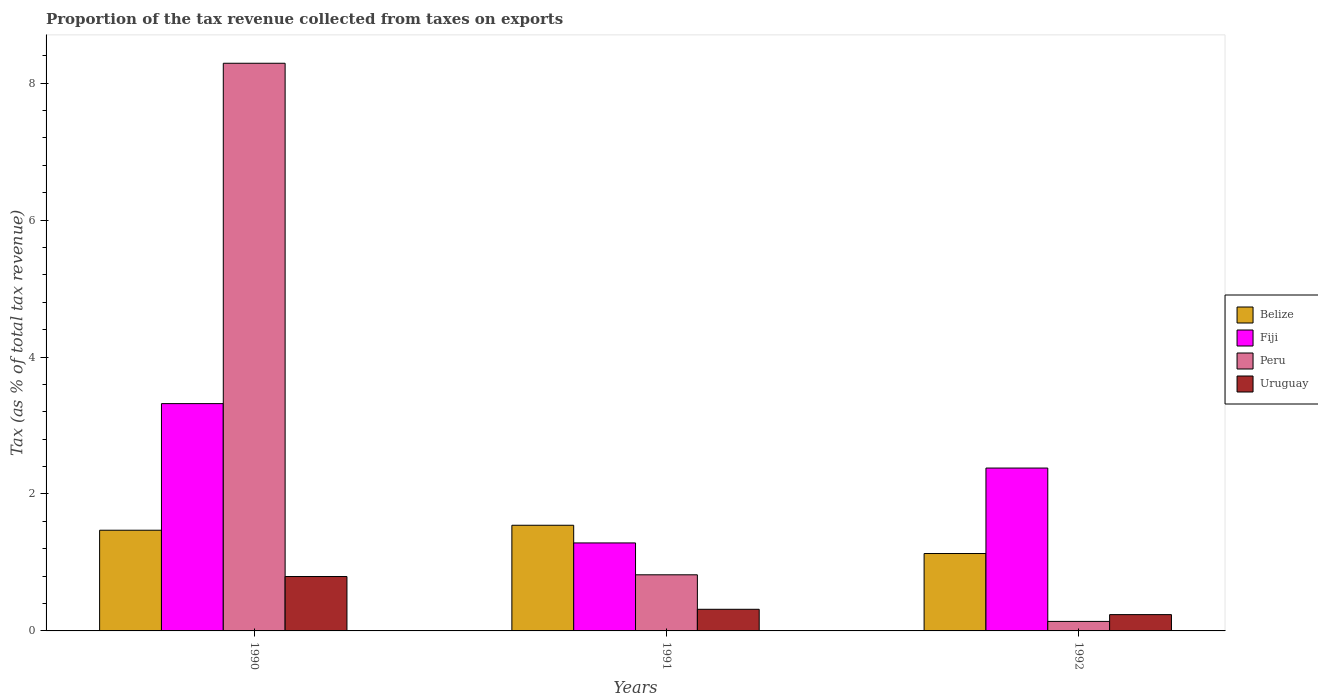How many different coloured bars are there?
Your response must be concise. 4. Are the number of bars per tick equal to the number of legend labels?
Give a very brief answer. Yes. In how many cases, is the number of bars for a given year not equal to the number of legend labels?
Provide a short and direct response. 0. What is the proportion of the tax revenue collected in Peru in 1992?
Ensure brevity in your answer.  0.14. Across all years, what is the maximum proportion of the tax revenue collected in Uruguay?
Offer a very short reply. 0.79. Across all years, what is the minimum proportion of the tax revenue collected in Belize?
Your answer should be compact. 1.13. What is the total proportion of the tax revenue collected in Peru in the graph?
Make the answer very short. 9.25. What is the difference between the proportion of the tax revenue collected in Fiji in 1991 and that in 1992?
Provide a succinct answer. -1.09. What is the difference between the proportion of the tax revenue collected in Uruguay in 1992 and the proportion of the tax revenue collected in Belize in 1990?
Ensure brevity in your answer.  -1.23. What is the average proportion of the tax revenue collected in Fiji per year?
Keep it short and to the point. 2.33. In the year 1990, what is the difference between the proportion of the tax revenue collected in Belize and proportion of the tax revenue collected in Fiji?
Offer a terse response. -1.85. In how many years, is the proportion of the tax revenue collected in Fiji greater than 7.2 %?
Provide a succinct answer. 0. What is the ratio of the proportion of the tax revenue collected in Uruguay in 1990 to that in 1991?
Keep it short and to the point. 2.51. Is the proportion of the tax revenue collected in Belize in 1990 less than that in 1991?
Offer a very short reply. Yes. What is the difference between the highest and the second highest proportion of the tax revenue collected in Belize?
Ensure brevity in your answer.  0.07. What is the difference between the highest and the lowest proportion of the tax revenue collected in Belize?
Your response must be concise. 0.41. In how many years, is the proportion of the tax revenue collected in Belize greater than the average proportion of the tax revenue collected in Belize taken over all years?
Give a very brief answer. 2. Is it the case that in every year, the sum of the proportion of the tax revenue collected in Belize and proportion of the tax revenue collected in Peru is greater than the sum of proportion of the tax revenue collected in Fiji and proportion of the tax revenue collected in Uruguay?
Offer a very short reply. No. What does the 1st bar from the left in 1991 represents?
Keep it short and to the point. Belize. What does the 4th bar from the right in 1991 represents?
Your answer should be compact. Belize. How many bars are there?
Your answer should be compact. 12. Does the graph contain any zero values?
Provide a succinct answer. No. Where does the legend appear in the graph?
Ensure brevity in your answer.  Center right. How many legend labels are there?
Your answer should be very brief. 4. What is the title of the graph?
Your answer should be compact. Proportion of the tax revenue collected from taxes on exports. What is the label or title of the Y-axis?
Your response must be concise. Tax (as % of total tax revenue). What is the Tax (as % of total tax revenue) in Belize in 1990?
Give a very brief answer. 1.47. What is the Tax (as % of total tax revenue) of Fiji in 1990?
Ensure brevity in your answer.  3.32. What is the Tax (as % of total tax revenue) of Peru in 1990?
Your answer should be compact. 8.29. What is the Tax (as % of total tax revenue) of Uruguay in 1990?
Keep it short and to the point. 0.79. What is the Tax (as % of total tax revenue) in Belize in 1991?
Provide a short and direct response. 1.54. What is the Tax (as % of total tax revenue) of Fiji in 1991?
Ensure brevity in your answer.  1.29. What is the Tax (as % of total tax revenue) of Peru in 1991?
Give a very brief answer. 0.82. What is the Tax (as % of total tax revenue) of Uruguay in 1991?
Your answer should be very brief. 0.32. What is the Tax (as % of total tax revenue) of Belize in 1992?
Provide a short and direct response. 1.13. What is the Tax (as % of total tax revenue) in Fiji in 1992?
Your answer should be compact. 2.38. What is the Tax (as % of total tax revenue) in Peru in 1992?
Your response must be concise. 0.14. What is the Tax (as % of total tax revenue) of Uruguay in 1992?
Give a very brief answer. 0.24. Across all years, what is the maximum Tax (as % of total tax revenue) in Belize?
Your answer should be compact. 1.54. Across all years, what is the maximum Tax (as % of total tax revenue) in Fiji?
Your answer should be very brief. 3.32. Across all years, what is the maximum Tax (as % of total tax revenue) of Peru?
Your response must be concise. 8.29. Across all years, what is the maximum Tax (as % of total tax revenue) in Uruguay?
Provide a succinct answer. 0.79. Across all years, what is the minimum Tax (as % of total tax revenue) in Belize?
Your answer should be compact. 1.13. Across all years, what is the minimum Tax (as % of total tax revenue) in Fiji?
Your answer should be very brief. 1.29. Across all years, what is the minimum Tax (as % of total tax revenue) in Peru?
Your answer should be very brief. 0.14. Across all years, what is the minimum Tax (as % of total tax revenue) in Uruguay?
Your answer should be compact. 0.24. What is the total Tax (as % of total tax revenue) in Belize in the graph?
Keep it short and to the point. 4.14. What is the total Tax (as % of total tax revenue) in Fiji in the graph?
Your answer should be very brief. 6.98. What is the total Tax (as % of total tax revenue) of Peru in the graph?
Ensure brevity in your answer.  9.25. What is the total Tax (as % of total tax revenue) in Uruguay in the graph?
Make the answer very short. 1.35. What is the difference between the Tax (as % of total tax revenue) in Belize in 1990 and that in 1991?
Your answer should be compact. -0.07. What is the difference between the Tax (as % of total tax revenue) of Fiji in 1990 and that in 1991?
Keep it short and to the point. 2.03. What is the difference between the Tax (as % of total tax revenue) of Peru in 1990 and that in 1991?
Give a very brief answer. 7.47. What is the difference between the Tax (as % of total tax revenue) of Uruguay in 1990 and that in 1991?
Your answer should be very brief. 0.48. What is the difference between the Tax (as % of total tax revenue) in Belize in 1990 and that in 1992?
Offer a very short reply. 0.34. What is the difference between the Tax (as % of total tax revenue) of Fiji in 1990 and that in 1992?
Keep it short and to the point. 0.94. What is the difference between the Tax (as % of total tax revenue) of Peru in 1990 and that in 1992?
Your answer should be very brief. 8.15. What is the difference between the Tax (as % of total tax revenue) of Uruguay in 1990 and that in 1992?
Make the answer very short. 0.56. What is the difference between the Tax (as % of total tax revenue) in Belize in 1991 and that in 1992?
Provide a succinct answer. 0.41. What is the difference between the Tax (as % of total tax revenue) in Fiji in 1991 and that in 1992?
Keep it short and to the point. -1.09. What is the difference between the Tax (as % of total tax revenue) in Peru in 1991 and that in 1992?
Ensure brevity in your answer.  0.68. What is the difference between the Tax (as % of total tax revenue) in Uruguay in 1991 and that in 1992?
Keep it short and to the point. 0.08. What is the difference between the Tax (as % of total tax revenue) in Belize in 1990 and the Tax (as % of total tax revenue) in Fiji in 1991?
Ensure brevity in your answer.  0.19. What is the difference between the Tax (as % of total tax revenue) of Belize in 1990 and the Tax (as % of total tax revenue) of Peru in 1991?
Your answer should be very brief. 0.65. What is the difference between the Tax (as % of total tax revenue) of Belize in 1990 and the Tax (as % of total tax revenue) of Uruguay in 1991?
Make the answer very short. 1.15. What is the difference between the Tax (as % of total tax revenue) of Fiji in 1990 and the Tax (as % of total tax revenue) of Peru in 1991?
Provide a succinct answer. 2.5. What is the difference between the Tax (as % of total tax revenue) in Fiji in 1990 and the Tax (as % of total tax revenue) in Uruguay in 1991?
Offer a terse response. 3. What is the difference between the Tax (as % of total tax revenue) in Peru in 1990 and the Tax (as % of total tax revenue) in Uruguay in 1991?
Your response must be concise. 7.98. What is the difference between the Tax (as % of total tax revenue) in Belize in 1990 and the Tax (as % of total tax revenue) in Fiji in 1992?
Your response must be concise. -0.91. What is the difference between the Tax (as % of total tax revenue) in Belize in 1990 and the Tax (as % of total tax revenue) in Peru in 1992?
Provide a succinct answer. 1.33. What is the difference between the Tax (as % of total tax revenue) in Belize in 1990 and the Tax (as % of total tax revenue) in Uruguay in 1992?
Offer a very short reply. 1.23. What is the difference between the Tax (as % of total tax revenue) of Fiji in 1990 and the Tax (as % of total tax revenue) of Peru in 1992?
Keep it short and to the point. 3.18. What is the difference between the Tax (as % of total tax revenue) of Fiji in 1990 and the Tax (as % of total tax revenue) of Uruguay in 1992?
Offer a terse response. 3.08. What is the difference between the Tax (as % of total tax revenue) in Peru in 1990 and the Tax (as % of total tax revenue) in Uruguay in 1992?
Make the answer very short. 8.05. What is the difference between the Tax (as % of total tax revenue) in Belize in 1991 and the Tax (as % of total tax revenue) in Fiji in 1992?
Give a very brief answer. -0.84. What is the difference between the Tax (as % of total tax revenue) of Belize in 1991 and the Tax (as % of total tax revenue) of Peru in 1992?
Your answer should be very brief. 1.4. What is the difference between the Tax (as % of total tax revenue) in Belize in 1991 and the Tax (as % of total tax revenue) in Uruguay in 1992?
Your answer should be compact. 1.31. What is the difference between the Tax (as % of total tax revenue) of Fiji in 1991 and the Tax (as % of total tax revenue) of Peru in 1992?
Give a very brief answer. 1.15. What is the difference between the Tax (as % of total tax revenue) in Fiji in 1991 and the Tax (as % of total tax revenue) in Uruguay in 1992?
Offer a terse response. 1.05. What is the difference between the Tax (as % of total tax revenue) in Peru in 1991 and the Tax (as % of total tax revenue) in Uruguay in 1992?
Provide a short and direct response. 0.58. What is the average Tax (as % of total tax revenue) of Belize per year?
Your response must be concise. 1.38. What is the average Tax (as % of total tax revenue) in Fiji per year?
Provide a short and direct response. 2.33. What is the average Tax (as % of total tax revenue) in Peru per year?
Make the answer very short. 3.08. What is the average Tax (as % of total tax revenue) in Uruguay per year?
Make the answer very short. 0.45. In the year 1990, what is the difference between the Tax (as % of total tax revenue) in Belize and Tax (as % of total tax revenue) in Fiji?
Offer a very short reply. -1.85. In the year 1990, what is the difference between the Tax (as % of total tax revenue) of Belize and Tax (as % of total tax revenue) of Peru?
Offer a terse response. -6.82. In the year 1990, what is the difference between the Tax (as % of total tax revenue) of Belize and Tax (as % of total tax revenue) of Uruguay?
Make the answer very short. 0.68. In the year 1990, what is the difference between the Tax (as % of total tax revenue) in Fiji and Tax (as % of total tax revenue) in Peru?
Provide a short and direct response. -4.97. In the year 1990, what is the difference between the Tax (as % of total tax revenue) of Fiji and Tax (as % of total tax revenue) of Uruguay?
Your answer should be compact. 2.53. In the year 1990, what is the difference between the Tax (as % of total tax revenue) of Peru and Tax (as % of total tax revenue) of Uruguay?
Your response must be concise. 7.5. In the year 1991, what is the difference between the Tax (as % of total tax revenue) in Belize and Tax (as % of total tax revenue) in Fiji?
Provide a succinct answer. 0.26. In the year 1991, what is the difference between the Tax (as % of total tax revenue) of Belize and Tax (as % of total tax revenue) of Peru?
Make the answer very short. 0.72. In the year 1991, what is the difference between the Tax (as % of total tax revenue) in Belize and Tax (as % of total tax revenue) in Uruguay?
Keep it short and to the point. 1.23. In the year 1991, what is the difference between the Tax (as % of total tax revenue) in Fiji and Tax (as % of total tax revenue) in Peru?
Make the answer very short. 0.47. In the year 1991, what is the difference between the Tax (as % of total tax revenue) of Fiji and Tax (as % of total tax revenue) of Uruguay?
Make the answer very short. 0.97. In the year 1991, what is the difference between the Tax (as % of total tax revenue) of Peru and Tax (as % of total tax revenue) of Uruguay?
Make the answer very short. 0.5. In the year 1992, what is the difference between the Tax (as % of total tax revenue) in Belize and Tax (as % of total tax revenue) in Fiji?
Keep it short and to the point. -1.25. In the year 1992, what is the difference between the Tax (as % of total tax revenue) in Belize and Tax (as % of total tax revenue) in Uruguay?
Provide a short and direct response. 0.89. In the year 1992, what is the difference between the Tax (as % of total tax revenue) of Fiji and Tax (as % of total tax revenue) of Peru?
Provide a short and direct response. 2.24. In the year 1992, what is the difference between the Tax (as % of total tax revenue) of Fiji and Tax (as % of total tax revenue) of Uruguay?
Provide a short and direct response. 2.14. In the year 1992, what is the difference between the Tax (as % of total tax revenue) of Peru and Tax (as % of total tax revenue) of Uruguay?
Your response must be concise. -0.1. What is the ratio of the Tax (as % of total tax revenue) of Belize in 1990 to that in 1991?
Make the answer very short. 0.95. What is the ratio of the Tax (as % of total tax revenue) of Fiji in 1990 to that in 1991?
Ensure brevity in your answer.  2.58. What is the ratio of the Tax (as % of total tax revenue) of Peru in 1990 to that in 1991?
Give a very brief answer. 10.11. What is the ratio of the Tax (as % of total tax revenue) in Uruguay in 1990 to that in 1991?
Your answer should be compact. 2.51. What is the ratio of the Tax (as % of total tax revenue) of Belize in 1990 to that in 1992?
Provide a succinct answer. 1.3. What is the ratio of the Tax (as % of total tax revenue) in Fiji in 1990 to that in 1992?
Give a very brief answer. 1.4. What is the ratio of the Tax (as % of total tax revenue) in Peru in 1990 to that in 1992?
Make the answer very short. 59.74. What is the ratio of the Tax (as % of total tax revenue) in Uruguay in 1990 to that in 1992?
Your answer should be very brief. 3.34. What is the ratio of the Tax (as % of total tax revenue) in Belize in 1991 to that in 1992?
Provide a succinct answer. 1.37. What is the ratio of the Tax (as % of total tax revenue) in Fiji in 1991 to that in 1992?
Ensure brevity in your answer.  0.54. What is the ratio of the Tax (as % of total tax revenue) of Peru in 1991 to that in 1992?
Provide a succinct answer. 5.91. What is the ratio of the Tax (as % of total tax revenue) of Uruguay in 1991 to that in 1992?
Make the answer very short. 1.33. What is the difference between the highest and the second highest Tax (as % of total tax revenue) in Belize?
Make the answer very short. 0.07. What is the difference between the highest and the second highest Tax (as % of total tax revenue) in Fiji?
Your response must be concise. 0.94. What is the difference between the highest and the second highest Tax (as % of total tax revenue) of Peru?
Provide a succinct answer. 7.47. What is the difference between the highest and the second highest Tax (as % of total tax revenue) of Uruguay?
Make the answer very short. 0.48. What is the difference between the highest and the lowest Tax (as % of total tax revenue) of Belize?
Your response must be concise. 0.41. What is the difference between the highest and the lowest Tax (as % of total tax revenue) in Fiji?
Make the answer very short. 2.03. What is the difference between the highest and the lowest Tax (as % of total tax revenue) of Peru?
Give a very brief answer. 8.15. What is the difference between the highest and the lowest Tax (as % of total tax revenue) of Uruguay?
Provide a succinct answer. 0.56. 